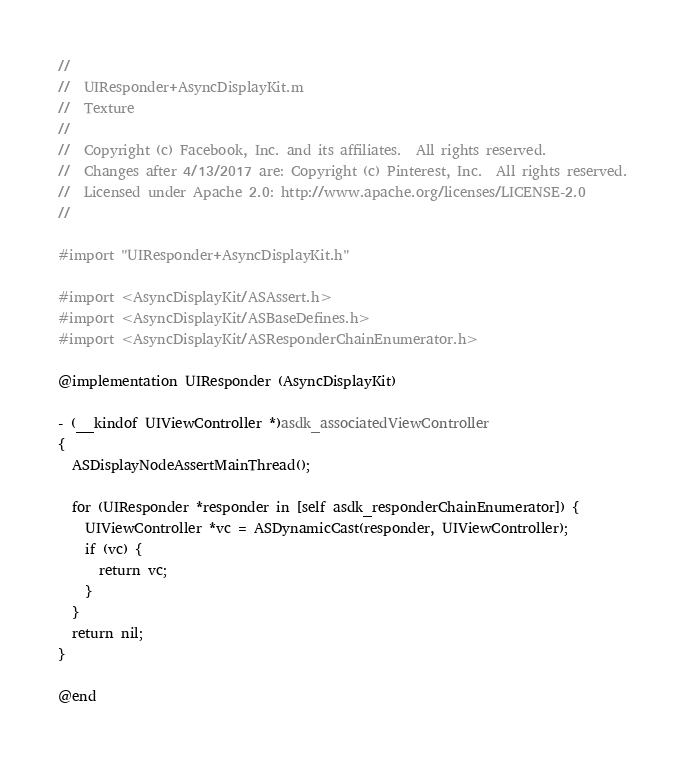<code> <loc_0><loc_0><loc_500><loc_500><_ObjectiveC_>//
//  UIResponder+AsyncDisplayKit.m
//  Texture
//
//  Copyright (c) Facebook, Inc. and its affiliates.  All rights reserved.
//  Changes after 4/13/2017 are: Copyright (c) Pinterest, Inc.  All rights reserved.
//  Licensed under Apache 2.0: http://www.apache.org/licenses/LICENSE-2.0
//

#import "UIResponder+AsyncDisplayKit.h"

#import <AsyncDisplayKit/ASAssert.h>
#import <AsyncDisplayKit/ASBaseDefines.h>
#import <AsyncDisplayKit/ASResponderChainEnumerator.h>

@implementation UIResponder (AsyncDisplayKit)

- (__kindof UIViewController *)asdk_associatedViewController
{
  ASDisplayNodeAssertMainThread();
  
  for (UIResponder *responder in [self asdk_responderChainEnumerator]) {
    UIViewController *vc = ASDynamicCast(responder, UIViewController);
    if (vc) {
      return vc;
    }
  }
  return nil;
}

@end

</code> 